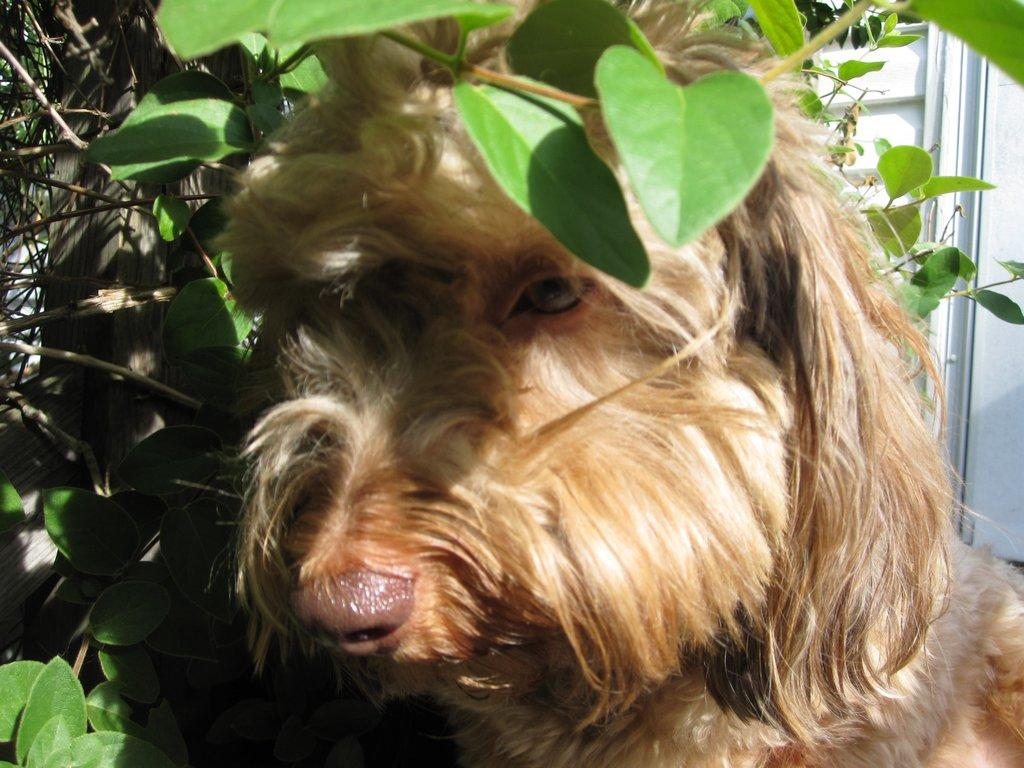What type of animal is present in the image? There is a dog in the image. What natural elements can be seen in the image? There are leaves in the image. What is visible in the background of the image? There is a wall in the background of the image. What type of gloves can be seen on the dog in the image? There are no gloves present in the image, and the dog is not wearing any. 